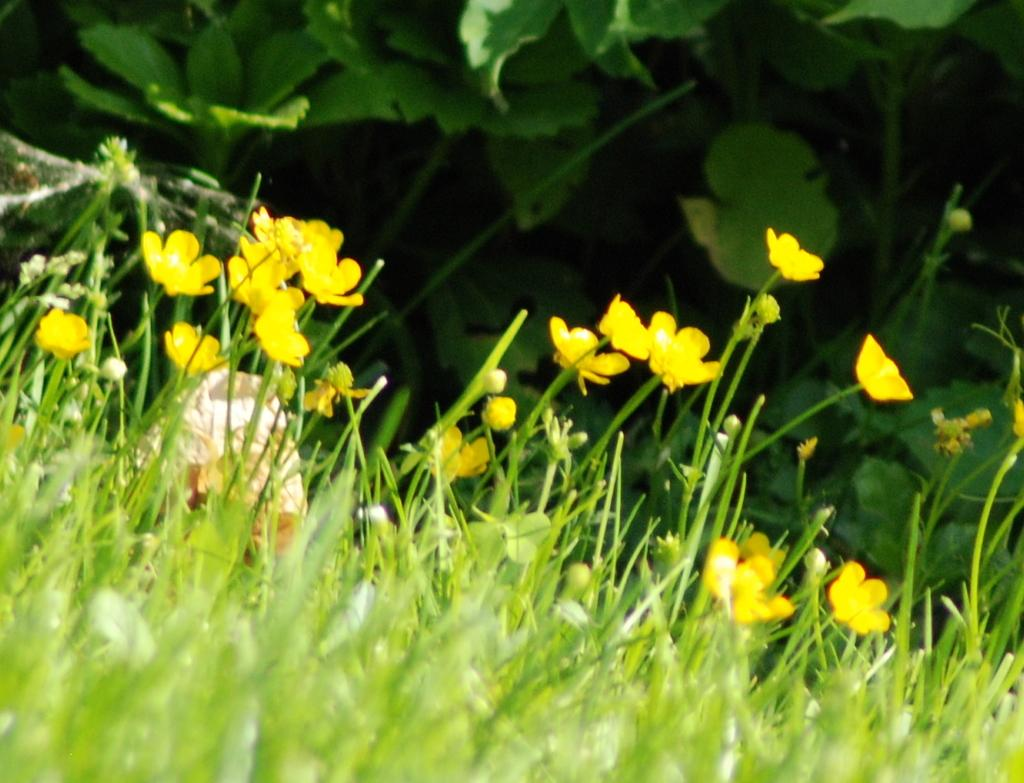What type of plants can be seen in the image? There are flowers, buds, stems, and leaves visible in the image. What is at the bottom of the image? There is grass at the bottom of the image. Can you describe the background of the image? The background of the image includes leaves and other objects. What time of day is it in the image, and what type of powder is being used in the hall? The time of day and the presence of powder or a hall cannot be determined from the image, as it only features flowers, buds, stems, grass, and leaves. 